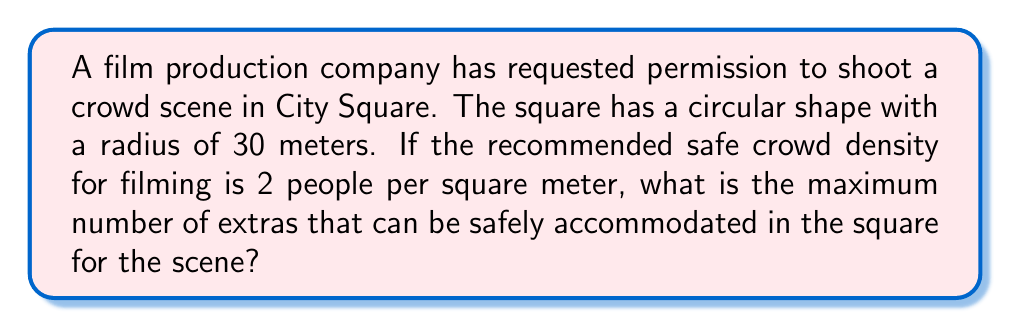Can you answer this question? To solve this problem, we need to follow these steps:

1. Calculate the area of the circular City Square:
   The area of a circle is given by the formula $A = \pi r^2$, where $r$ is the radius.
   
   $$A = \pi (30\text{ m})^2 = 900\pi\text{ m}^2$$

2. Convert the crowd density to people per square meter:
   The given density is 2 people per square meter, which we can express as:
   
   $$\text{Density} = \frac{2\text{ people}}{1\text{ m}^2}$$

3. Calculate the maximum number of people:
   To find the maximum number of people, we multiply the area by the density:
   
   $$\text{Maximum people} = \text{Area} \times \text{Density}$$
   $$= 900\pi\text{ m}^2 \times \frac{2\text{ people}}{1\text{ m}^2}$$
   $$= 1800\pi\text{ people}$$

4. Round down to the nearest whole number:
   Since we can't have a fractional number of people, we need to round down to ensure we stay within the safe limit.
   
   $$1800\pi \approx 5654.87$$

Therefore, the maximum number of extras that can be safely accommodated is 5654.
Answer: 5654 extras 